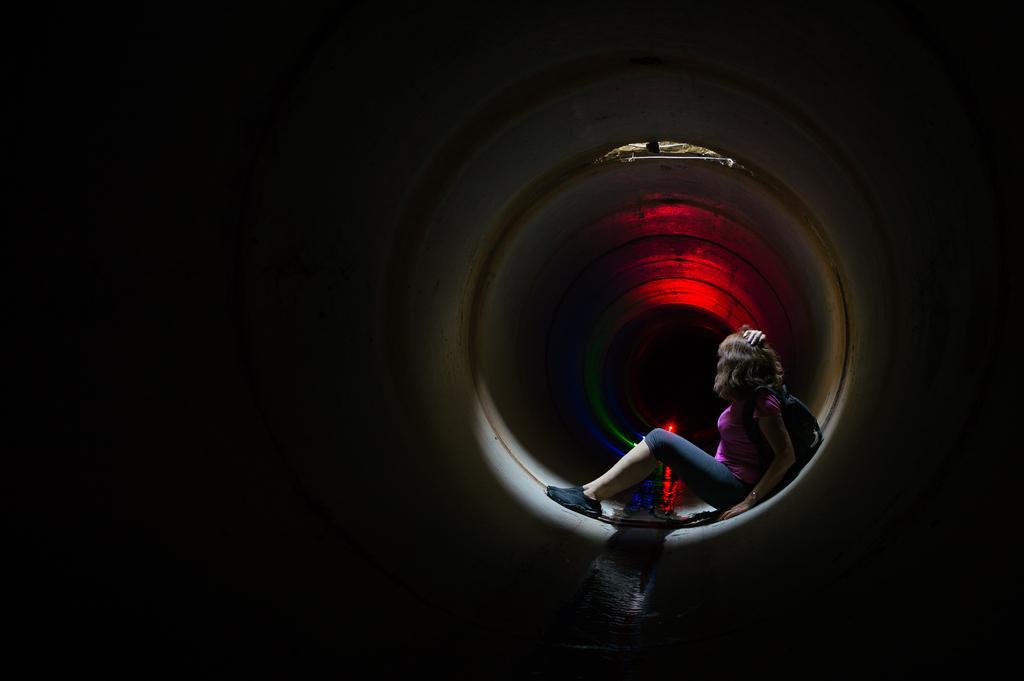Could you give a brief overview of what you see in this image? In this image, I can see the woman sitting. It looks like a pipe. In the background, I can see the lighting´s. 